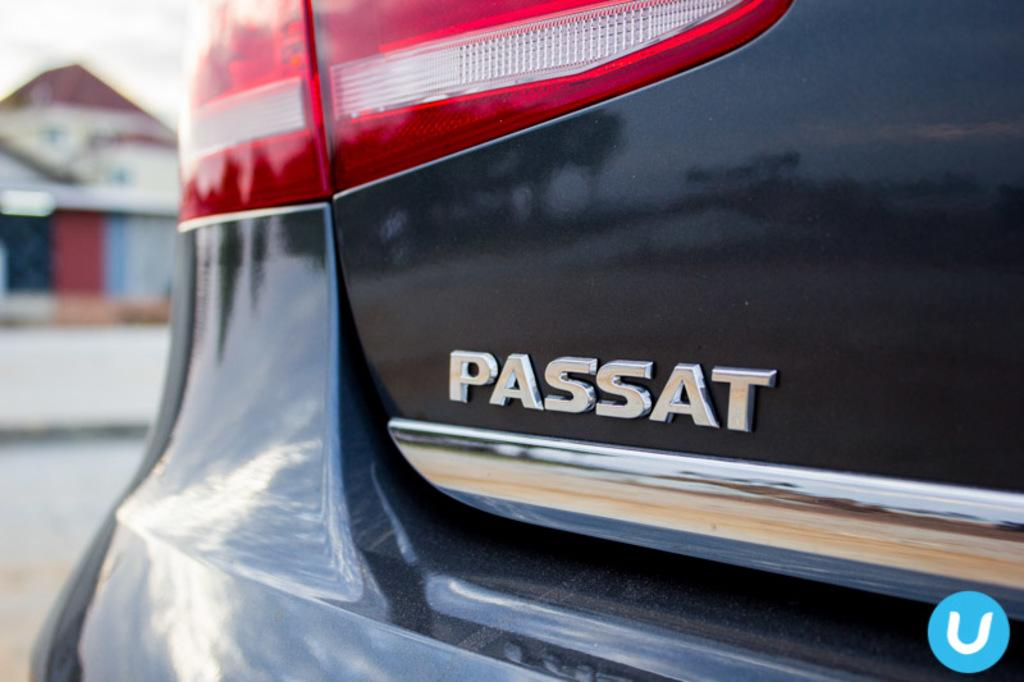What part of a car is visible in the image? The tail lamp of a car is visible in the image. Is there any branding or identification on the car? Yes, there is a logo on the car. What can be seen in the background of the image? There is a building in the background of the image, but it is blurred. Can you tell me how many women are visible in the image? There are no women present in the image; it features the tail lamp of a car and a blurred building in the background. 